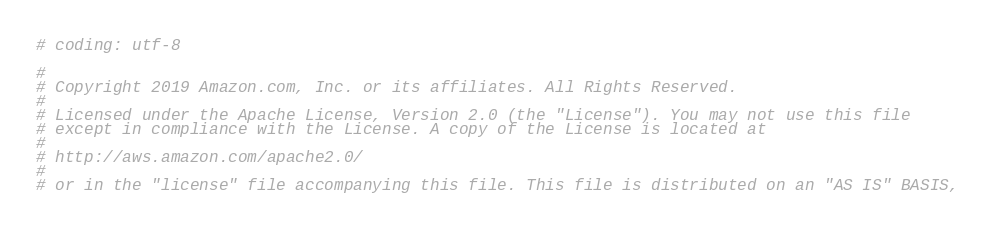<code> <loc_0><loc_0><loc_500><loc_500><_Python_># coding: utf-8

#
# Copyright 2019 Amazon.com, Inc. or its affiliates. All Rights Reserved.
#
# Licensed under the Apache License, Version 2.0 (the "License"). You may not use this file
# except in compliance with the License. A copy of the License is located at
#
# http://aws.amazon.com/apache2.0/
#
# or in the "license" file accompanying this file. This file is distributed on an "AS IS" BASIS,</code> 